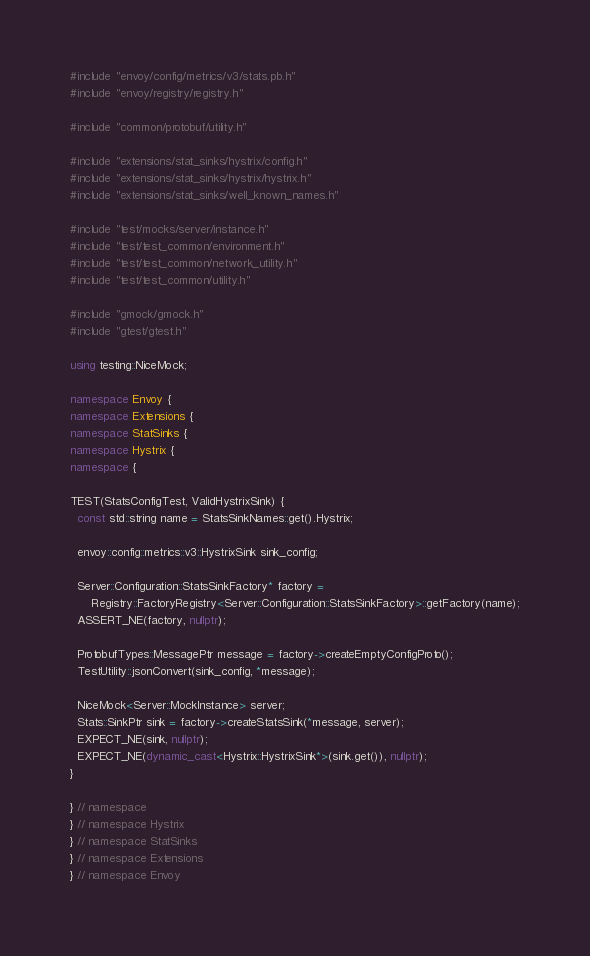Convert code to text. <code><loc_0><loc_0><loc_500><loc_500><_C++_>#include "envoy/config/metrics/v3/stats.pb.h"
#include "envoy/registry/registry.h"

#include "common/protobuf/utility.h"

#include "extensions/stat_sinks/hystrix/config.h"
#include "extensions/stat_sinks/hystrix/hystrix.h"
#include "extensions/stat_sinks/well_known_names.h"

#include "test/mocks/server/instance.h"
#include "test/test_common/environment.h"
#include "test/test_common/network_utility.h"
#include "test/test_common/utility.h"

#include "gmock/gmock.h"
#include "gtest/gtest.h"

using testing::NiceMock;

namespace Envoy {
namespace Extensions {
namespace StatSinks {
namespace Hystrix {
namespace {

TEST(StatsConfigTest, ValidHystrixSink) {
  const std::string name = StatsSinkNames::get().Hystrix;

  envoy::config::metrics::v3::HystrixSink sink_config;

  Server::Configuration::StatsSinkFactory* factory =
      Registry::FactoryRegistry<Server::Configuration::StatsSinkFactory>::getFactory(name);
  ASSERT_NE(factory, nullptr);

  ProtobufTypes::MessagePtr message = factory->createEmptyConfigProto();
  TestUtility::jsonConvert(sink_config, *message);

  NiceMock<Server::MockInstance> server;
  Stats::SinkPtr sink = factory->createStatsSink(*message, server);
  EXPECT_NE(sink, nullptr);
  EXPECT_NE(dynamic_cast<Hystrix::HystrixSink*>(sink.get()), nullptr);
}

} // namespace
} // namespace Hystrix
} // namespace StatSinks
} // namespace Extensions
} // namespace Envoy
</code> 